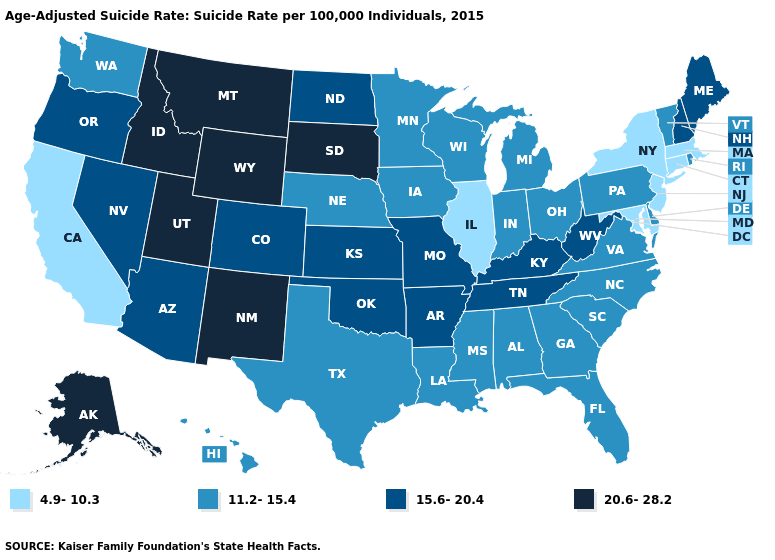What is the value of Oregon?
Short answer required. 15.6-20.4. What is the highest value in the MidWest ?
Quick response, please. 20.6-28.2. Among the states that border New York , does Vermont have the highest value?
Be succinct. Yes. Name the states that have a value in the range 4.9-10.3?
Keep it brief. California, Connecticut, Illinois, Maryland, Massachusetts, New Jersey, New York. What is the value of Illinois?
Concise answer only. 4.9-10.3. Name the states that have a value in the range 15.6-20.4?
Be succinct. Arizona, Arkansas, Colorado, Kansas, Kentucky, Maine, Missouri, Nevada, New Hampshire, North Dakota, Oklahoma, Oregon, Tennessee, West Virginia. Name the states that have a value in the range 11.2-15.4?
Give a very brief answer. Alabama, Delaware, Florida, Georgia, Hawaii, Indiana, Iowa, Louisiana, Michigan, Minnesota, Mississippi, Nebraska, North Carolina, Ohio, Pennsylvania, Rhode Island, South Carolina, Texas, Vermont, Virginia, Washington, Wisconsin. Name the states that have a value in the range 15.6-20.4?
Give a very brief answer. Arizona, Arkansas, Colorado, Kansas, Kentucky, Maine, Missouri, Nevada, New Hampshire, North Dakota, Oklahoma, Oregon, Tennessee, West Virginia. Does New Jersey have the lowest value in the USA?
Keep it brief. Yes. What is the value of Tennessee?
Be succinct. 15.6-20.4. Name the states that have a value in the range 20.6-28.2?
Be succinct. Alaska, Idaho, Montana, New Mexico, South Dakota, Utah, Wyoming. Does Pennsylvania have the highest value in the USA?
Give a very brief answer. No. Which states have the lowest value in the South?
Quick response, please. Maryland. Name the states that have a value in the range 4.9-10.3?
Give a very brief answer. California, Connecticut, Illinois, Maryland, Massachusetts, New Jersey, New York. 